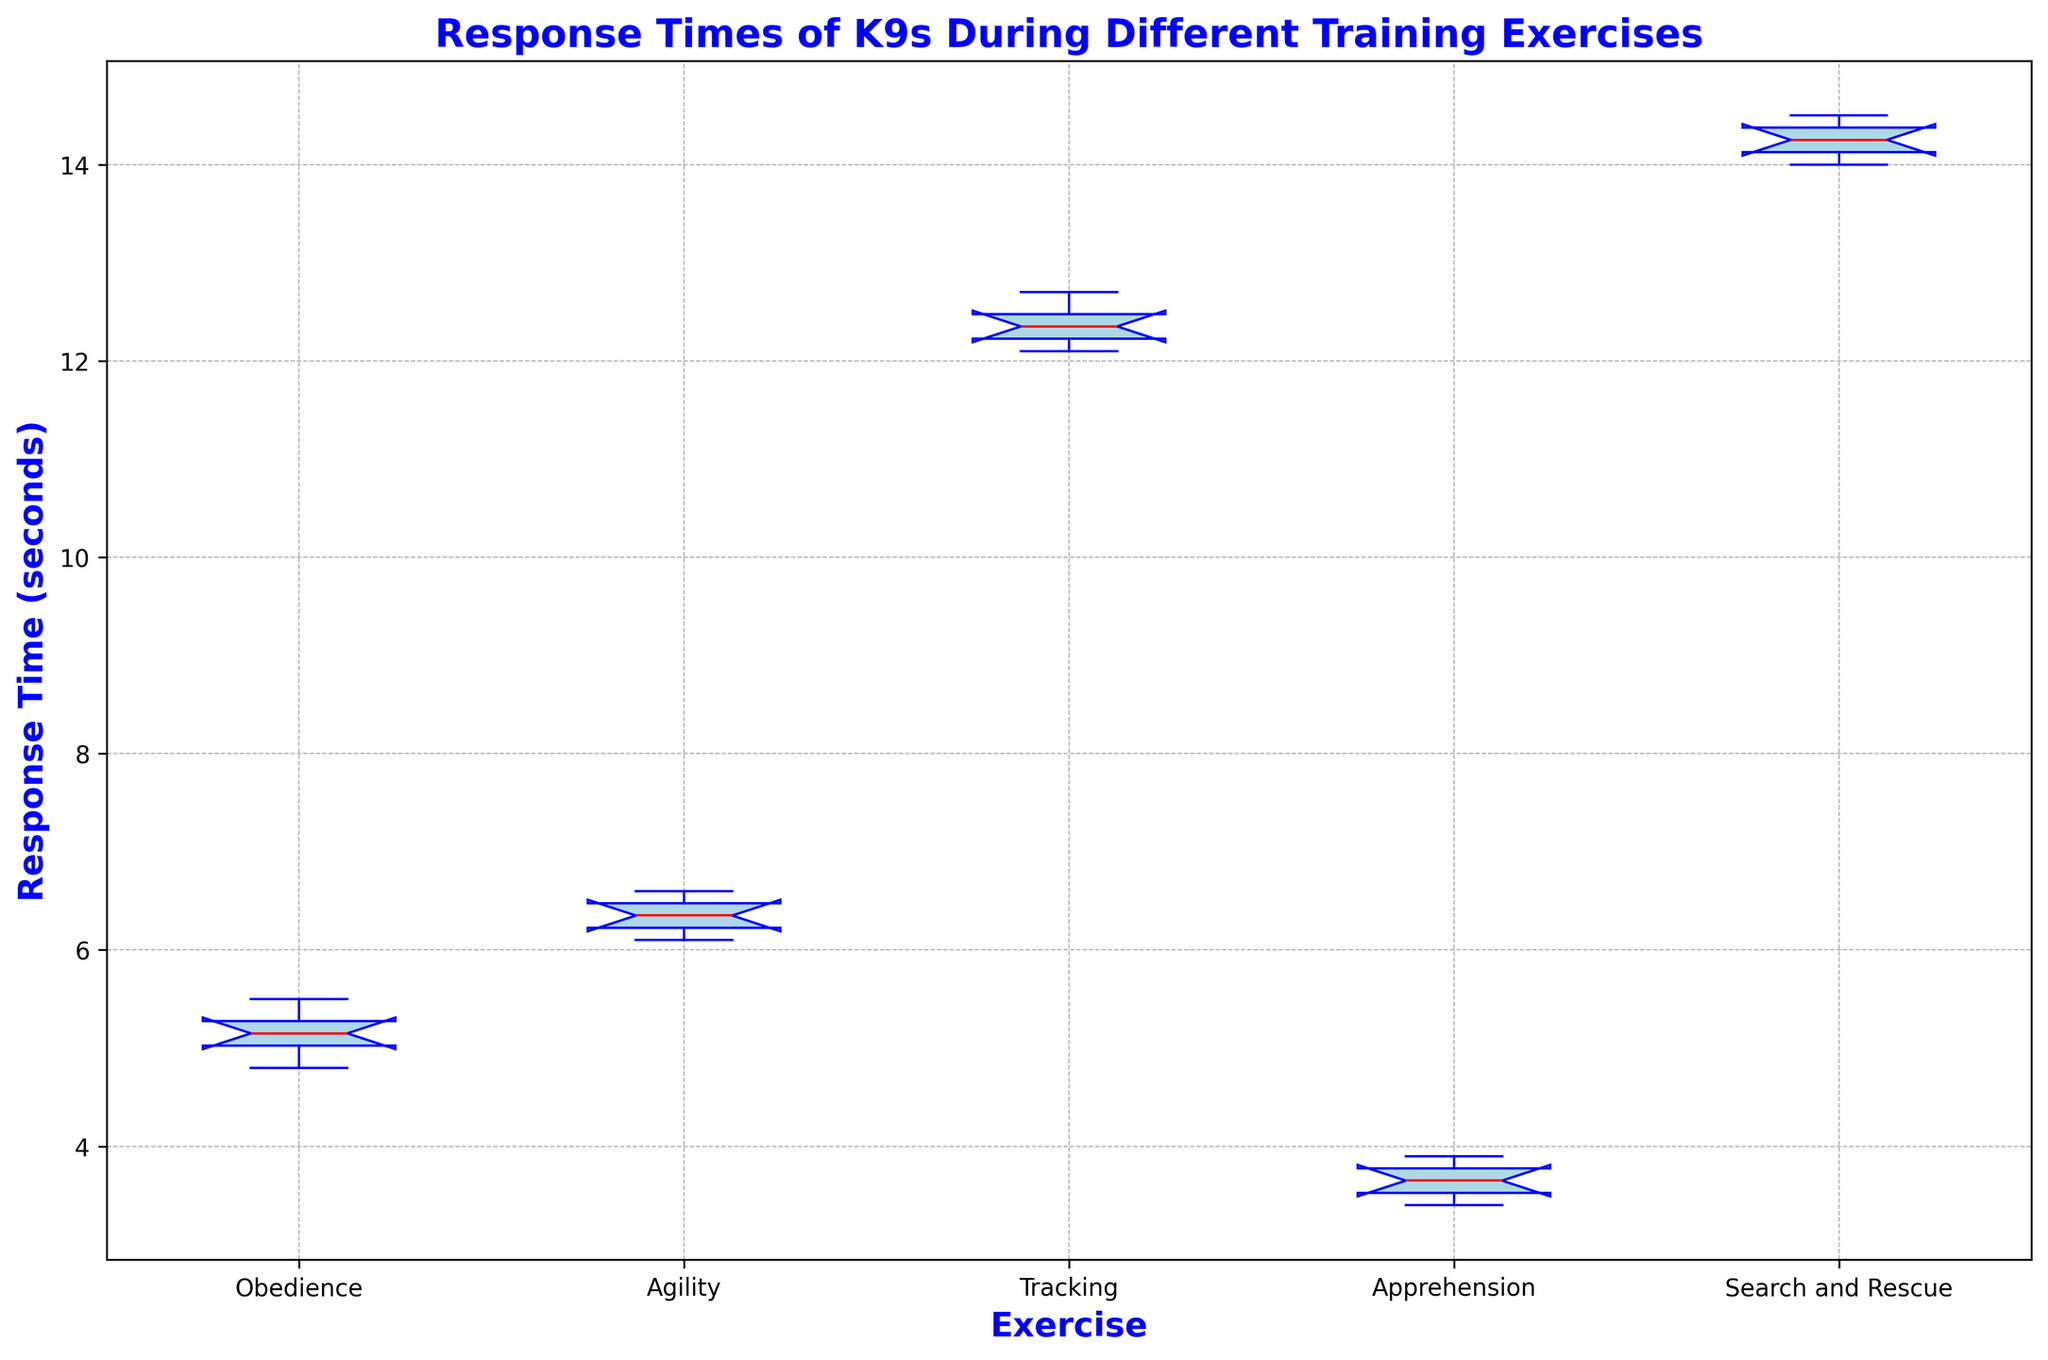Q: Which exercise has the lowest median response time? The median is indicated by the red line inside each box on the plot. Locate and compare these lines across the different exercises to find the lowest.
Answer: Apprehension Q: What is the range of response times for the Agility exercise? The range can be determined by subtracting the smallest value (bottom of whisker) from the largest value (top of whisker) in the Agility boxplot.
Answer: 0.5 seconds Q: Compare the interquartile ranges (IQR) of Obedience and Tracking exercises. Which is larger? The IQR is represented by the height of the box. Compare the heights of the boxes for Obedience and Tracking to determine which one is larger.
Answer: Tracking Q: How many exercises have a median response time greater than 6 seconds? Identify the median lines (red) and count how many boxes have these medians above the 6-second mark.
Answer: 2 Q: What can you say about the variance in response times for the Search and Rescue exercise based on the plot? Variance is visually indicated by the spread of the box and whiskers. A larger spread indicates higher variance. Assess the relative spread of the Search and Rescue box and whiskers.
Answer: High variance Q: Which exercise has the most similar median response time to that of the Agility exercise? Locate the median line (red) for Agility and find the exercise whose median line is closest in value.
Answer: Obedience Q: Are there any outliers in the response times data? If so, for which exercise? Outliers are typically represented by small circles beyond the whiskers in a boxplot. Identify any such points and the corresponding exercise(s).
Answer: No outliers Q: What is the approximate difference between the median response times of Obedience and Search and Rescue exercises? Find the median lines (red) for both exercises, then calculate the difference between these two values.
Answer: ~9 seconds Q: Which exercise exhibits the smallest interquartile range (IQR)? Compare the height of the boxes for each exercise and determine which one is the smallest.
Answer: Apprehension Q: Is the median response time for the Tracking exercise closer to the median response time of the Agility exercise or the Search and Rescue exercise? Compare the median lines (red) of the Tracking exercise with those of Agility and Search and Rescue to see which is closer in value.
Answer: Search and Rescue 